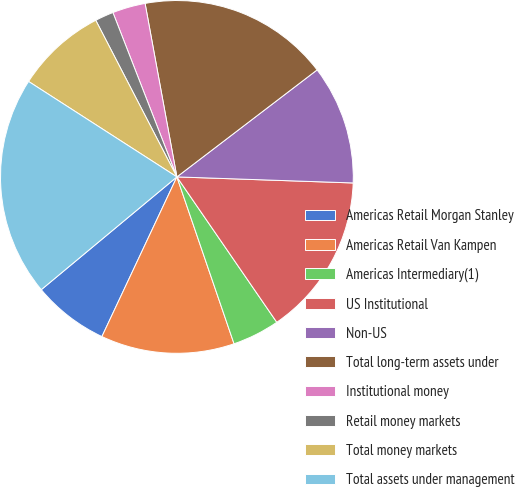Convert chart. <chart><loc_0><loc_0><loc_500><loc_500><pie_chart><fcel>Americas Retail Morgan Stanley<fcel>Americas Retail Van Kampen<fcel>Americas Intermediary(1)<fcel>US Institutional<fcel>Non-US<fcel>Total long-term assets under<fcel>Institutional money<fcel>Retail money markets<fcel>Total money markets<fcel>Total assets under management<nl><fcel>6.97%<fcel>12.24%<fcel>4.33%<fcel>14.87%<fcel>10.92%<fcel>17.51%<fcel>3.02%<fcel>1.7%<fcel>8.29%<fcel>20.14%<nl></chart> 